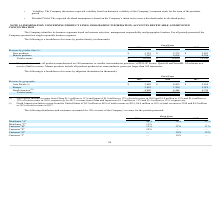From Quicklogic Corporation's financial document, What are the respective revenue from new products in 2018 and 2019? The document shows two values: $5,735 and $3,123 (in thousands). From the document: "New products $ 3,123 $ 5,735 $ 5,853 New products $ 3,123 $ 5,735 $ 5,853..." Also, What are the respective revenue from mature products in 2018 and 2019? The document shows two values: 6,894 and 7,187 (in thousands). From the document: "Mature products 7,187 6,894 6,296 Mature products 7,187 6,894 6,296..." Also, What are the respective total revenue in 2018 and 2019?  The document shows two values: $12,629 and $10,310 (in thousands). From the document: "Total revenue $ 10,310 $ 12,629 $ 12,149 Total revenue $ 10,310 $ 12,629 $ 12,149..." Also, can you calculate: What is the total revenue from new products in 2018 and 2019? Based on the calculation:  ($5,735 + $3,123) , the result is 8858 (in thousands). This is based on the information: "New products $ 3,123 $ 5,735 $ 5,853 New products $ 3,123 $ 5,735 $ 5,853..." The key data points involved are: 3,123, 5,735. Also, can you calculate: What is the average revenue from mature products in 2018 and 2019? To answer this question, I need to perform calculations using the financial data. The calculation is:  (6,894 + 7,187)/2 , which equals 7040.5 (in thousands). This is based on the information: "Mature products 7,187 6,894 6,296 Mature products 7,187 6,894 6,296..." The key data points involved are: 6,894, 7,187. Also, can you calculate: What is the percentage change in total revenue between 2018 and 2019? To answer this question, I need to perform calculations using the financial data. The calculation is: (10,310 - 12,629)/12,629 , which equals -18.36 (percentage). This is based on the information: "Total revenue $ 10,310 $ 12,629 $ 12,149 Total revenue $ 10,310 $ 12,629 $ 12,149..." The key data points involved are: 10,310, 12,629. 